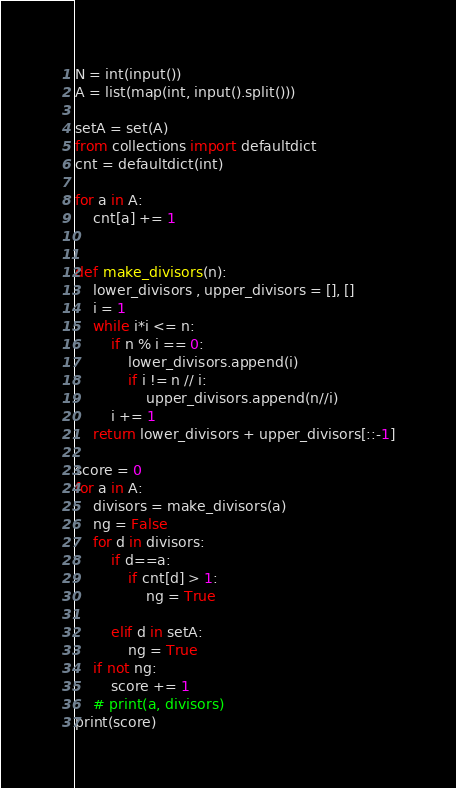<code> <loc_0><loc_0><loc_500><loc_500><_Python_>N = int(input())
A = list(map(int, input().split()))

setA = set(A)
from collections import defaultdict
cnt = defaultdict(int)

for a in A:
    cnt[a] += 1


def make_divisors(n):
    lower_divisors , upper_divisors = [], []
    i = 1
    while i*i <= n:
        if n % i == 0:
            lower_divisors.append(i)
            if i != n // i:
                upper_divisors.append(n//i)
        i += 1
    return lower_divisors + upper_divisors[::-1]

score = 0
for a in A:
    divisors = make_divisors(a)
    ng = False
    for d in divisors:
        if d==a:
            if cnt[d] > 1:
                ng = True

        elif d in setA:
            ng = True
    if not ng:
        score += 1
    # print(a, divisors)
print(score)
</code> 